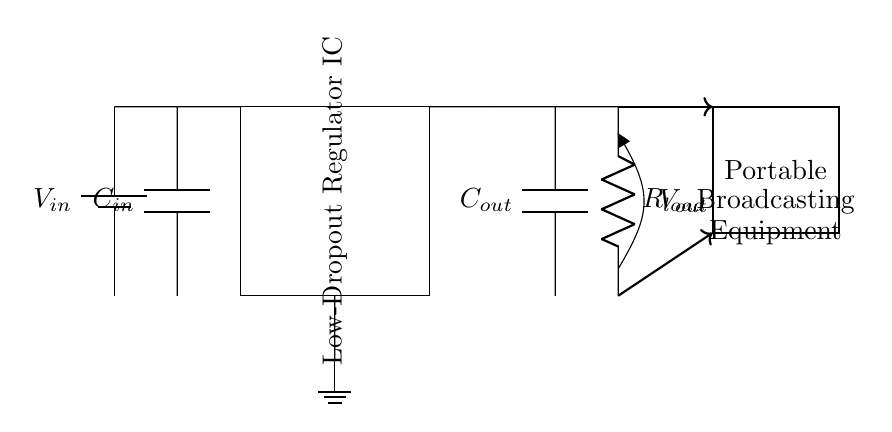What is the input voltage for this circuit? The input voltage is labeled as V_in at the battery, which is where the circuit receives its power.
Answer: V_in What component is used as the load in this circuit? The load is represented by R_load, a resistor, which is the component that consumes power from the circuit.
Answer: R_load What is the function of capacitor C_in? Capacitor C_in is used for input filtering to stabilize the input voltage and reduce ripple before it reaches the regulator.
Answer: Input filtering What is the purpose of the low-dropout regulator IC? The low-dropout regulator IC is designed to maintain a steady output voltage (V_out) even when the input voltage is close to the desired output voltage.
Answer: Steady output voltage Which component is used for output filtering? Capacitor C_out is the component used for output filtering to smooth out the output voltage supplied to the load.
Answer: C_out What is the output voltage labeled as in the circuit? The output voltage is labeled as V_out, indicating the voltage that the load receives.
Answer: V_out How does the load connect to the output in this circuit? The load connects directly to the output voltage, with R_load receiving voltage from the output capacitor C_out.
Answer: Directly 